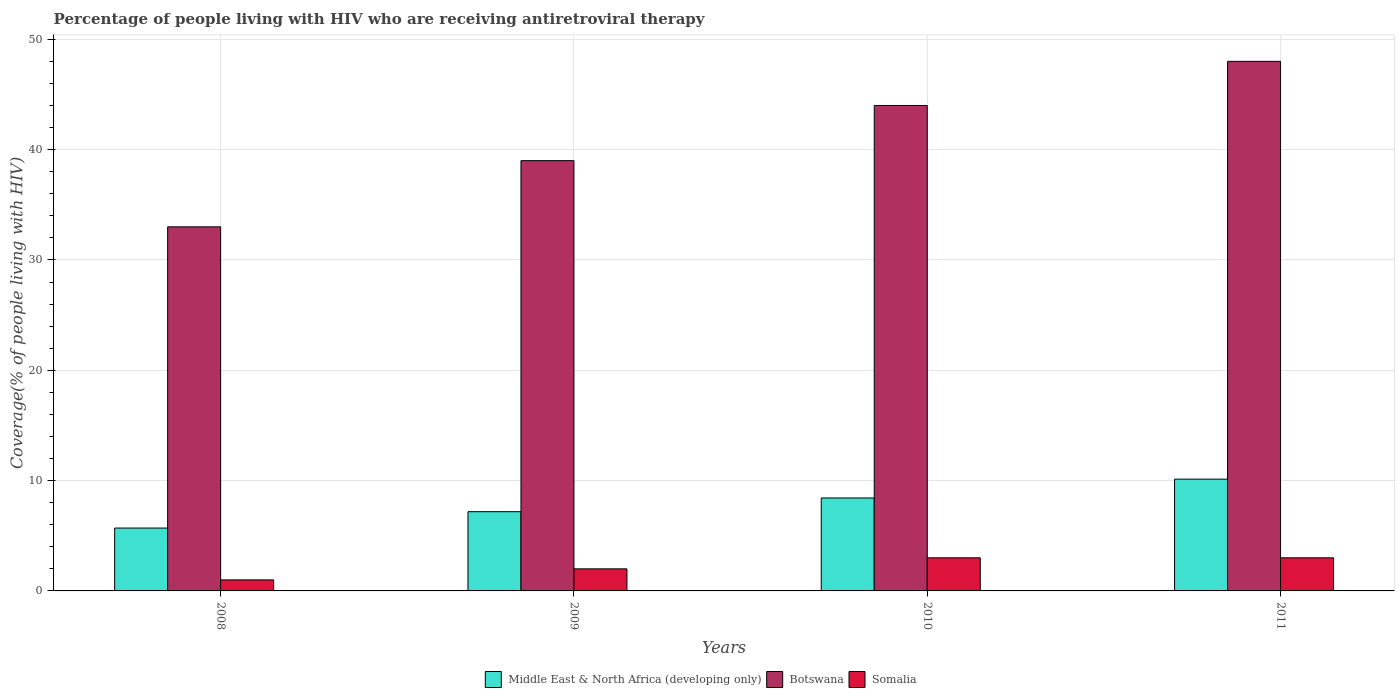Are the number of bars on each tick of the X-axis equal?
Offer a terse response. Yes. How many bars are there on the 4th tick from the left?
Offer a very short reply. 3. How many bars are there on the 4th tick from the right?
Offer a terse response. 3. What is the percentage of the HIV infected people who are receiving antiretroviral therapy in Middle East & North Africa (developing only) in 2010?
Offer a terse response. 8.42. Across all years, what is the maximum percentage of the HIV infected people who are receiving antiretroviral therapy in Middle East & North Africa (developing only)?
Keep it short and to the point. 10.13. Across all years, what is the minimum percentage of the HIV infected people who are receiving antiretroviral therapy in Somalia?
Provide a short and direct response. 1. In which year was the percentage of the HIV infected people who are receiving antiretroviral therapy in Botswana maximum?
Keep it short and to the point. 2011. In which year was the percentage of the HIV infected people who are receiving antiretroviral therapy in Botswana minimum?
Offer a terse response. 2008. What is the total percentage of the HIV infected people who are receiving antiretroviral therapy in Botswana in the graph?
Provide a short and direct response. 164. What is the difference between the percentage of the HIV infected people who are receiving antiretroviral therapy in Somalia in 2008 and that in 2011?
Ensure brevity in your answer.  -2. What is the difference between the percentage of the HIV infected people who are receiving antiretroviral therapy in Somalia in 2011 and the percentage of the HIV infected people who are receiving antiretroviral therapy in Middle East & North Africa (developing only) in 2009?
Make the answer very short. -4.18. What is the average percentage of the HIV infected people who are receiving antiretroviral therapy in Botswana per year?
Your answer should be very brief. 41. In the year 2009, what is the difference between the percentage of the HIV infected people who are receiving antiretroviral therapy in Middle East & North Africa (developing only) and percentage of the HIV infected people who are receiving antiretroviral therapy in Somalia?
Your answer should be very brief. 5.18. In how many years, is the percentage of the HIV infected people who are receiving antiretroviral therapy in Botswana greater than 24 %?
Your response must be concise. 4. What is the difference between the highest and the lowest percentage of the HIV infected people who are receiving antiretroviral therapy in Middle East & North Africa (developing only)?
Your answer should be very brief. 4.43. In how many years, is the percentage of the HIV infected people who are receiving antiretroviral therapy in Middle East & North Africa (developing only) greater than the average percentage of the HIV infected people who are receiving antiretroviral therapy in Middle East & North Africa (developing only) taken over all years?
Make the answer very short. 2. What does the 3rd bar from the left in 2011 represents?
Give a very brief answer. Somalia. What does the 1st bar from the right in 2011 represents?
Keep it short and to the point. Somalia. Is it the case that in every year, the sum of the percentage of the HIV infected people who are receiving antiretroviral therapy in Somalia and percentage of the HIV infected people who are receiving antiretroviral therapy in Botswana is greater than the percentage of the HIV infected people who are receiving antiretroviral therapy in Middle East & North Africa (developing only)?
Offer a very short reply. Yes. Are the values on the major ticks of Y-axis written in scientific E-notation?
Provide a succinct answer. No. How are the legend labels stacked?
Make the answer very short. Horizontal. What is the title of the graph?
Keep it short and to the point. Percentage of people living with HIV who are receiving antiretroviral therapy. What is the label or title of the Y-axis?
Ensure brevity in your answer.  Coverage(% of people living with HIV). What is the Coverage(% of people living with HIV) of Middle East & North Africa (developing only) in 2008?
Your answer should be compact. 5.7. What is the Coverage(% of people living with HIV) in Somalia in 2008?
Ensure brevity in your answer.  1. What is the Coverage(% of people living with HIV) of Middle East & North Africa (developing only) in 2009?
Your response must be concise. 7.18. What is the Coverage(% of people living with HIV) of Middle East & North Africa (developing only) in 2010?
Offer a terse response. 8.42. What is the Coverage(% of people living with HIV) in Somalia in 2010?
Your answer should be very brief. 3. What is the Coverage(% of people living with HIV) of Middle East & North Africa (developing only) in 2011?
Provide a short and direct response. 10.13. What is the Coverage(% of people living with HIV) in Botswana in 2011?
Provide a succinct answer. 48. Across all years, what is the maximum Coverage(% of people living with HIV) in Middle East & North Africa (developing only)?
Provide a short and direct response. 10.13. Across all years, what is the maximum Coverage(% of people living with HIV) in Somalia?
Provide a succinct answer. 3. Across all years, what is the minimum Coverage(% of people living with HIV) in Middle East & North Africa (developing only)?
Give a very brief answer. 5.7. Across all years, what is the minimum Coverage(% of people living with HIV) of Botswana?
Provide a succinct answer. 33. What is the total Coverage(% of people living with HIV) in Middle East & North Africa (developing only) in the graph?
Your answer should be compact. 31.43. What is the total Coverage(% of people living with HIV) of Botswana in the graph?
Your response must be concise. 164. What is the difference between the Coverage(% of people living with HIV) in Middle East & North Africa (developing only) in 2008 and that in 2009?
Your response must be concise. -1.48. What is the difference between the Coverage(% of people living with HIV) of Botswana in 2008 and that in 2009?
Provide a short and direct response. -6. What is the difference between the Coverage(% of people living with HIV) of Somalia in 2008 and that in 2009?
Your answer should be compact. -1. What is the difference between the Coverage(% of people living with HIV) in Middle East & North Africa (developing only) in 2008 and that in 2010?
Offer a terse response. -2.73. What is the difference between the Coverage(% of people living with HIV) of Botswana in 2008 and that in 2010?
Provide a short and direct response. -11. What is the difference between the Coverage(% of people living with HIV) of Somalia in 2008 and that in 2010?
Your response must be concise. -2. What is the difference between the Coverage(% of people living with HIV) in Middle East & North Africa (developing only) in 2008 and that in 2011?
Your response must be concise. -4.43. What is the difference between the Coverage(% of people living with HIV) of Somalia in 2008 and that in 2011?
Your answer should be compact. -2. What is the difference between the Coverage(% of people living with HIV) of Middle East & North Africa (developing only) in 2009 and that in 2010?
Your answer should be very brief. -1.24. What is the difference between the Coverage(% of people living with HIV) in Somalia in 2009 and that in 2010?
Ensure brevity in your answer.  -1. What is the difference between the Coverage(% of people living with HIV) of Middle East & North Africa (developing only) in 2009 and that in 2011?
Provide a short and direct response. -2.95. What is the difference between the Coverage(% of people living with HIV) of Middle East & North Africa (developing only) in 2010 and that in 2011?
Keep it short and to the point. -1.71. What is the difference between the Coverage(% of people living with HIV) in Middle East & North Africa (developing only) in 2008 and the Coverage(% of people living with HIV) in Botswana in 2009?
Provide a short and direct response. -33.3. What is the difference between the Coverage(% of people living with HIV) in Middle East & North Africa (developing only) in 2008 and the Coverage(% of people living with HIV) in Somalia in 2009?
Your answer should be compact. 3.7. What is the difference between the Coverage(% of people living with HIV) of Middle East & North Africa (developing only) in 2008 and the Coverage(% of people living with HIV) of Botswana in 2010?
Your response must be concise. -38.3. What is the difference between the Coverage(% of people living with HIV) of Middle East & North Africa (developing only) in 2008 and the Coverage(% of people living with HIV) of Somalia in 2010?
Give a very brief answer. 2.7. What is the difference between the Coverage(% of people living with HIV) of Botswana in 2008 and the Coverage(% of people living with HIV) of Somalia in 2010?
Ensure brevity in your answer.  30. What is the difference between the Coverage(% of people living with HIV) of Middle East & North Africa (developing only) in 2008 and the Coverage(% of people living with HIV) of Botswana in 2011?
Offer a terse response. -42.3. What is the difference between the Coverage(% of people living with HIV) of Middle East & North Africa (developing only) in 2008 and the Coverage(% of people living with HIV) of Somalia in 2011?
Your answer should be very brief. 2.7. What is the difference between the Coverage(% of people living with HIV) in Botswana in 2008 and the Coverage(% of people living with HIV) in Somalia in 2011?
Your answer should be compact. 30. What is the difference between the Coverage(% of people living with HIV) of Middle East & North Africa (developing only) in 2009 and the Coverage(% of people living with HIV) of Botswana in 2010?
Your response must be concise. -36.82. What is the difference between the Coverage(% of people living with HIV) of Middle East & North Africa (developing only) in 2009 and the Coverage(% of people living with HIV) of Somalia in 2010?
Keep it short and to the point. 4.18. What is the difference between the Coverage(% of people living with HIV) of Botswana in 2009 and the Coverage(% of people living with HIV) of Somalia in 2010?
Your answer should be compact. 36. What is the difference between the Coverage(% of people living with HIV) in Middle East & North Africa (developing only) in 2009 and the Coverage(% of people living with HIV) in Botswana in 2011?
Give a very brief answer. -40.82. What is the difference between the Coverage(% of people living with HIV) in Middle East & North Africa (developing only) in 2009 and the Coverage(% of people living with HIV) in Somalia in 2011?
Keep it short and to the point. 4.18. What is the difference between the Coverage(% of people living with HIV) of Botswana in 2009 and the Coverage(% of people living with HIV) of Somalia in 2011?
Give a very brief answer. 36. What is the difference between the Coverage(% of people living with HIV) in Middle East & North Africa (developing only) in 2010 and the Coverage(% of people living with HIV) in Botswana in 2011?
Ensure brevity in your answer.  -39.58. What is the difference between the Coverage(% of people living with HIV) of Middle East & North Africa (developing only) in 2010 and the Coverage(% of people living with HIV) of Somalia in 2011?
Provide a short and direct response. 5.42. What is the average Coverage(% of people living with HIV) in Middle East & North Africa (developing only) per year?
Make the answer very short. 7.86. What is the average Coverage(% of people living with HIV) in Botswana per year?
Provide a short and direct response. 41. What is the average Coverage(% of people living with HIV) of Somalia per year?
Your response must be concise. 2.25. In the year 2008, what is the difference between the Coverage(% of people living with HIV) in Middle East & North Africa (developing only) and Coverage(% of people living with HIV) in Botswana?
Your answer should be very brief. -27.3. In the year 2008, what is the difference between the Coverage(% of people living with HIV) in Middle East & North Africa (developing only) and Coverage(% of people living with HIV) in Somalia?
Ensure brevity in your answer.  4.7. In the year 2008, what is the difference between the Coverage(% of people living with HIV) of Botswana and Coverage(% of people living with HIV) of Somalia?
Provide a succinct answer. 32. In the year 2009, what is the difference between the Coverage(% of people living with HIV) of Middle East & North Africa (developing only) and Coverage(% of people living with HIV) of Botswana?
Offer a terse response. -31.82. In the year 2009, what is the difference between the Coverage(% of people living with HIV) in Middle East & North Africa (developing only) and Coverage(% of people living with HIV) in Somalia?
Offer a terse response. 5.18. In the year 2009, what is the difference between the Coverage(% of people living with HIV) in Botswana and Coverage(% of people living with HIV) in Somalia?
Give a very brief answer. 37. In the year 2010, what is the difference between the Coverage(% of people living with HIV) in Middle East & North Africa (developing only) and Coverage(% of people living with HIV) in Botswana?
Your response must be concise. -35.58. In the year 2010, what is the difference between the Coverage(% of people living with HIV) of Middle East & North Africa (developing only) and Coverage(% of people living with HIV) of Somalia?
Make the answer very short. 5.42. In the year 2010, what is the difference between the Coverage(% of people living with HIV) in Botswana and Coverage(% of people living with HIV) in Somalia?
Provide a short and direct response. 41. In the year 2011, what is the difference between the Coverage(% of people living with HIV) of Middle East & North Africa (developing only) and Coverage(% of people living with HIV) of Botswana?
Offer a terse response. -37.87. In the year 2011, what is the difference between the Coverage(% of people living with HIV) in Middle East & North Africa (developing only) and Coverage(% of people living with HIV) in Somalia?
Keep it short and to the point. 7.13. In the year 2011, what is the difference between the Coverage(% of people living with HIV) of Botswana and Coverage(% of people living with HIV) of Somalia?
Your answer should be compact. 45. What is the ratio of the Coverage(% of people living with HIV) of Middle East & North Africa (developing only) in 2008 to that in 2009?
Your answer should be very brief. 0.79. What is the ratio of the Coverage(% of people living with HIV) of Botswana in 2008 to that in 2009?
Give a very brief answer. 0.85. What is the ratio of the Coverage(% of people living with HIV) in Somalia in 2008 to that in 2009?
Your answer should be compact. 0.5. What is the ratio of the Coverage(% of people living with HIV) in Middle East & North Africa (developing only) in 2008 to that in 2010?
Your answer should be very brief. 0.68. What is the ratio of the Coverage(% of people living with HIV) of Middle East & North Africa (developing only) in 2008 to that in 2011?
Provide a succinct answer. 0.56. What is the ratio of the Coverage(% of people living with HIV) in Botswana in 2008 to that in 2011?
Your answer should be very brief. 0.69. What is the ratio of the Coverage(% of people living with HIV) of Somalia in 2008 to that in 2011?
Make the answer very short. 0.33. What is the ratio of the Coverage(% of people living with HIV) in Middle East & North Africa (developing only) in 2009 to that in 2010?
Give a very brief answer. 0.85. What is the ratio of the Coverage(% of people living with HIV) of Botswana in 2009 to that in 2010?
Your response must be concise. 0.89. What is the ratio of the Coverage(% of people living with HIV) in Somalia in 2009 to that in 2010?
Provide a short and direct response. 0.67. What is the ratio of the Coverage(% of people living with HIV) in Middle East & North Africa (developing only) in 2009 to that in 2011?
Provide a succinct answer. 0.71. What is the ratio of the Coverage(% of people living with HIV) of Botswana in 2009 to that in 2011?
Offer a terse response. 0.81. What is the ratio of the Coverage(% of people living with HIV) in Somalia in 2009 to that in 2011?
Your answer should be very brief. 0.67. What is the ratio of the Coverage(% of people living with HIV) in Middle East & North Africa (developing only) in 2010 to that in 2011?
Provide a short and direct response. 0.83. What is the ratio of the Coverage(% of people living with HIV) in Somalia in 2010 to that in 2011?
Offer a very short reply. 1. What is the difference between the highest and the second highest Coverage(% of people living with HIV) of Middle East & North Africa (developing only)?
Offer a terse response. 1.71. What is the difference between the highest and the lowest Coverage(% of people living with HIV) in Middle East & North Africa (developing only)?
Give a very brief answer. 4.43. 